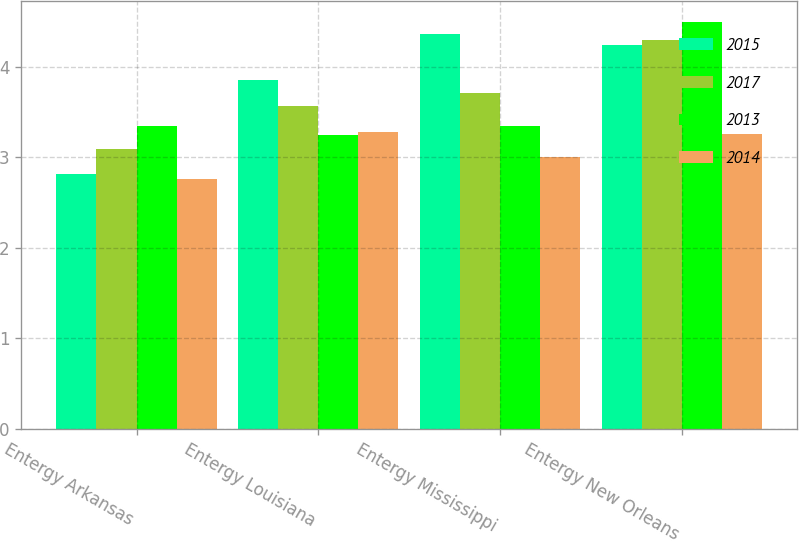<chart> <loc_0><loc_0><loc_500><loc_500><stacked_bar_chart><ecel><fcel>Entergy Arkansas<fcel>Entergy Louisiana<fcel>Entergy Mississippi<fcel>Entergy New Orleans<nl><fcel>2015<fcel>2.81<fcel>3.85<fcel>4.36<fcel>4.24<nl><fcel>2017<fcel>3.09<fcel>3.57<fcel>3.71<fcel>4.3<nl><fcel>2013<fcel>3.34<fcel>3.24<fcel>3.34<fcel>4.5<nl><fcel>2014<fcel>2.76<fcel>3.28<fcel>3<fcel>3.26<nl></chart> 